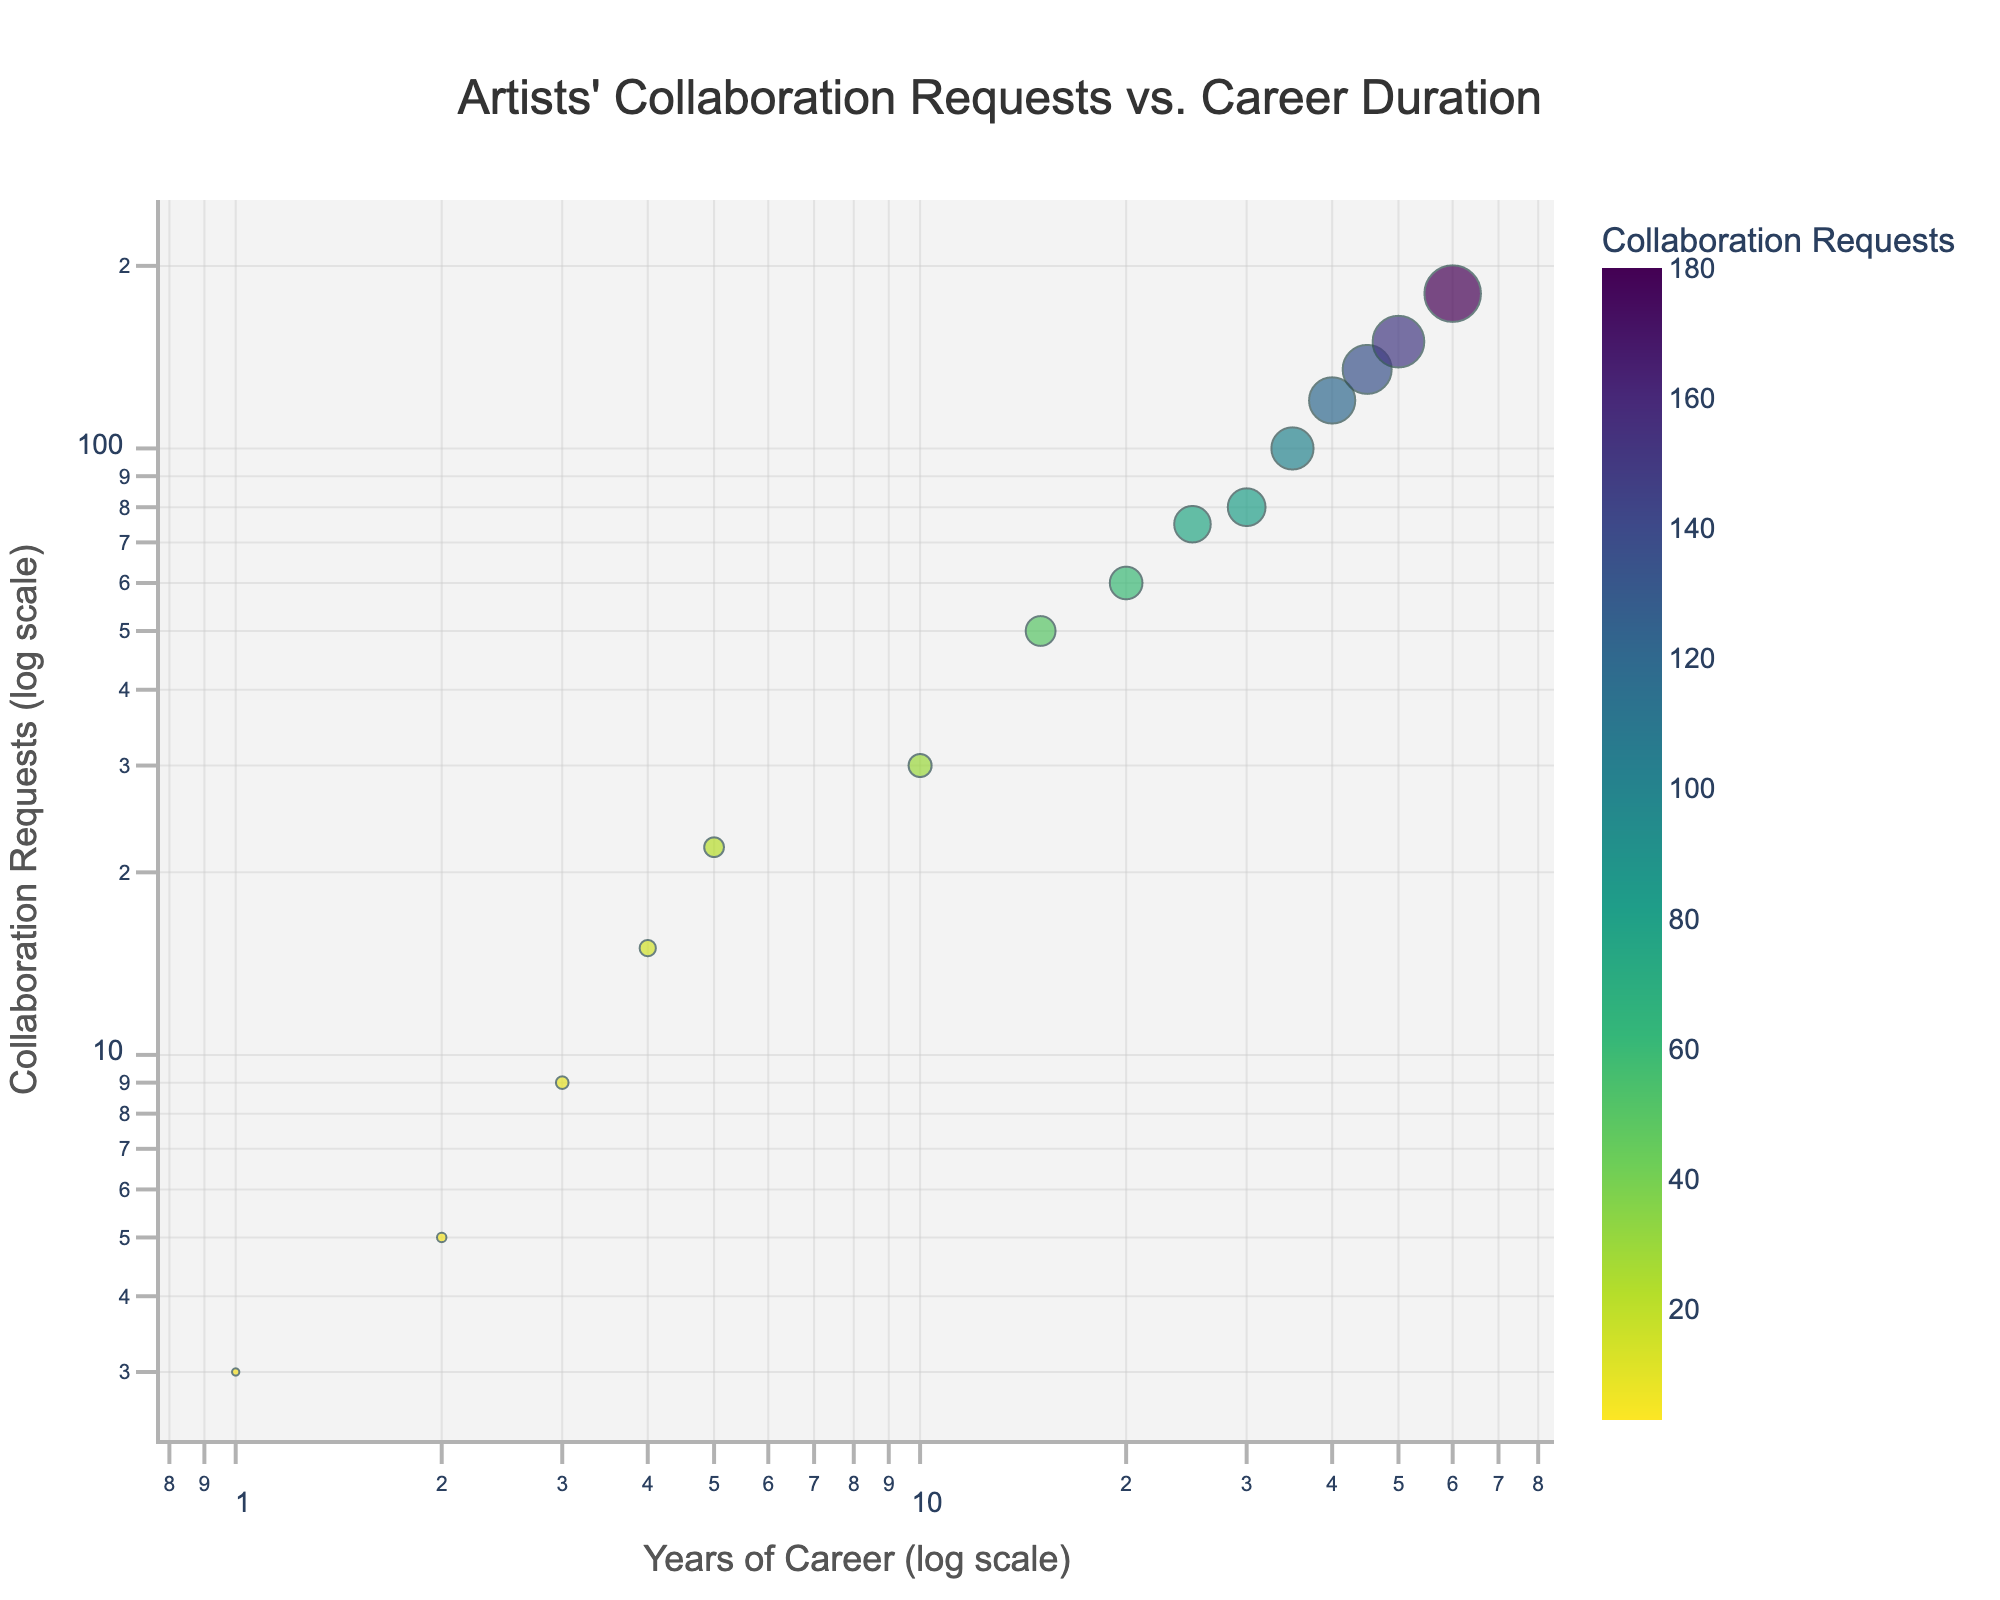Who is the artist that received the most collaboration requests? Examine the data points on the figure and identify the one with the highest y-value. Isabella Taylor has the highest y-value at 100 collaboration requests.
Answer: Isabella Taylor What is the title of the figure? The title is displayed prominently at the top center of the figure. It specifies the relationship being plotted.
Answer: Artists' Collaboration Requests vs. Career Duration How many years has David Smith been in his art career? Locate the data point labeled 'David Smith' using the hover functionality and check the x-value associated with his name.
Answer: 10 years Compare the collaboration requests between Sophia Brown and Olivia Garcia. Who has more? Look at the y-values for the points labeled 'Sophia Brown' and 'Olivia Garcia'. Sophia Brown has a y-value of 22, whereas Olivia Garcia has 50.
Answer: Olivia Garcia What is the trend shown in the plot between career duration and collaboration requests? Observe the overall direction and pattern of the data points on the log-log scale. The data points generally move upward and to the right.
Answer: Positive correlation Who has been in their career for the least amount of time and how many collaboration requests have they received? Identify the data point with the lowest x-value. Emma Davis at 1 year is the lowest and has 3 collaboration requests.
Answer: Emma Davis, 3 What is the average number of collaboration requests received by artists with over 20 years of career duration? Identify the artists who have more than 20 years in their career, sum their collaboration requests, and divide by the number of artists. [(60 + 75 + 80 + 100 + 120 + 135 + 150 + 180) / 8]
Answer: 112.5 Which artist has received fewer collaboration requests: Michael Lee or Daniel Martinez? Compare the y-values of data points labeled 'Michael Lee' and 'Daniel Martinez'. Michael Lee has 9 and Daniel Martinez has 15.
Answer: Michael Lee What is the color used for the data points in the figure? The color scale is mentioned to be sequential Viridis, which involves shades of green to purple.
Answer: Shades of Viridis Does Charlotte Lewis receive more collaboration requests per year compared to the average of all artists? Calculate the average requests per year for all artists. For Charlotte Lewis (150 / 50 = 3). Average requests per year for all is ((5 + 9 + 3 + 15 + 22 + 30 + 50 + 60 + 75 + 80 + 100 + 120 + 135 + 150 + 180) / (2 + 3 + 1 + 4 + 5 + 10 + 15 + 20 + 25 + 30 + 35 + 40 + 45 + 50 + 60)) = 2.39. Since 3 > 2.39, yes.
Answer: Yes 